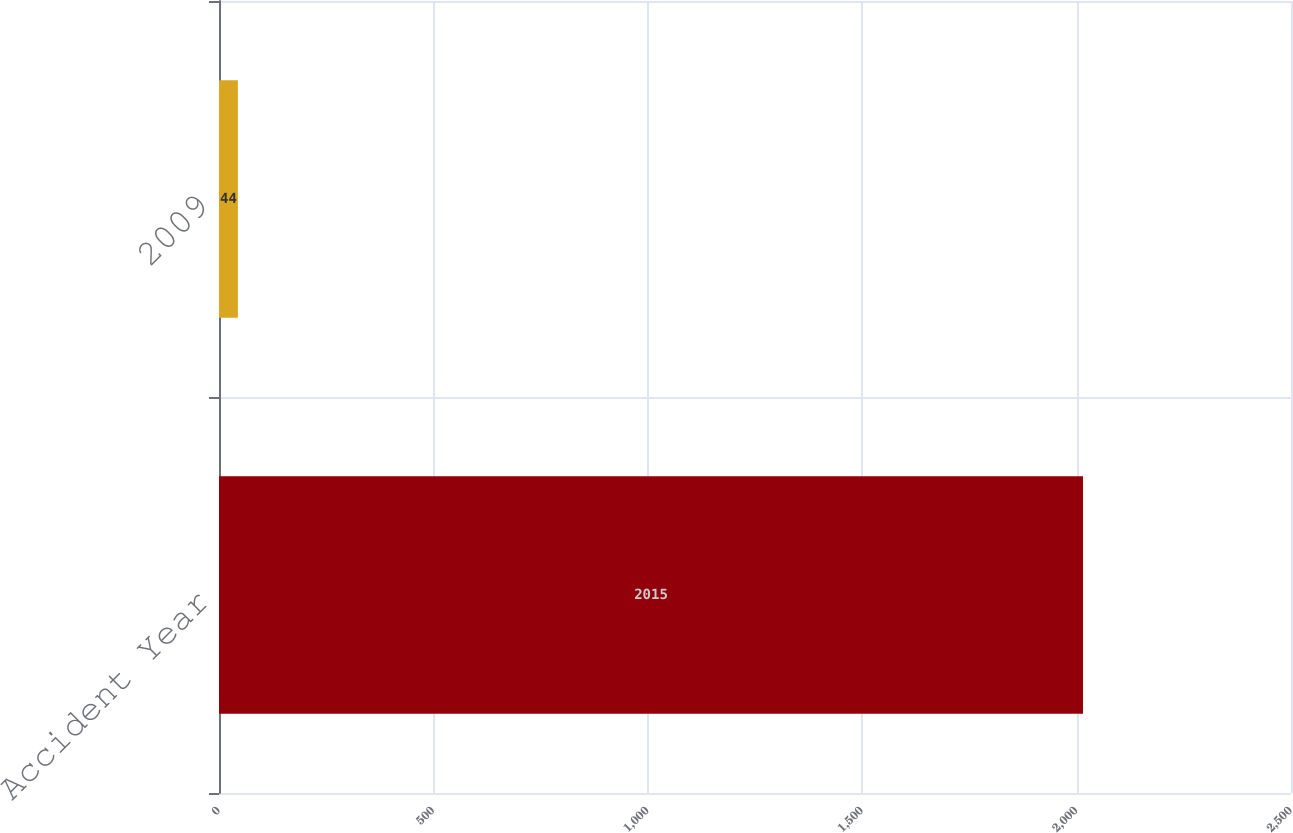Convert chart. <chart><loc_0><loc_0><loc_500><loc_500><bar_chart><fcel>Accident Year<fcel>2009<nl><fcel>2015<fcel>44<nl></chart> 